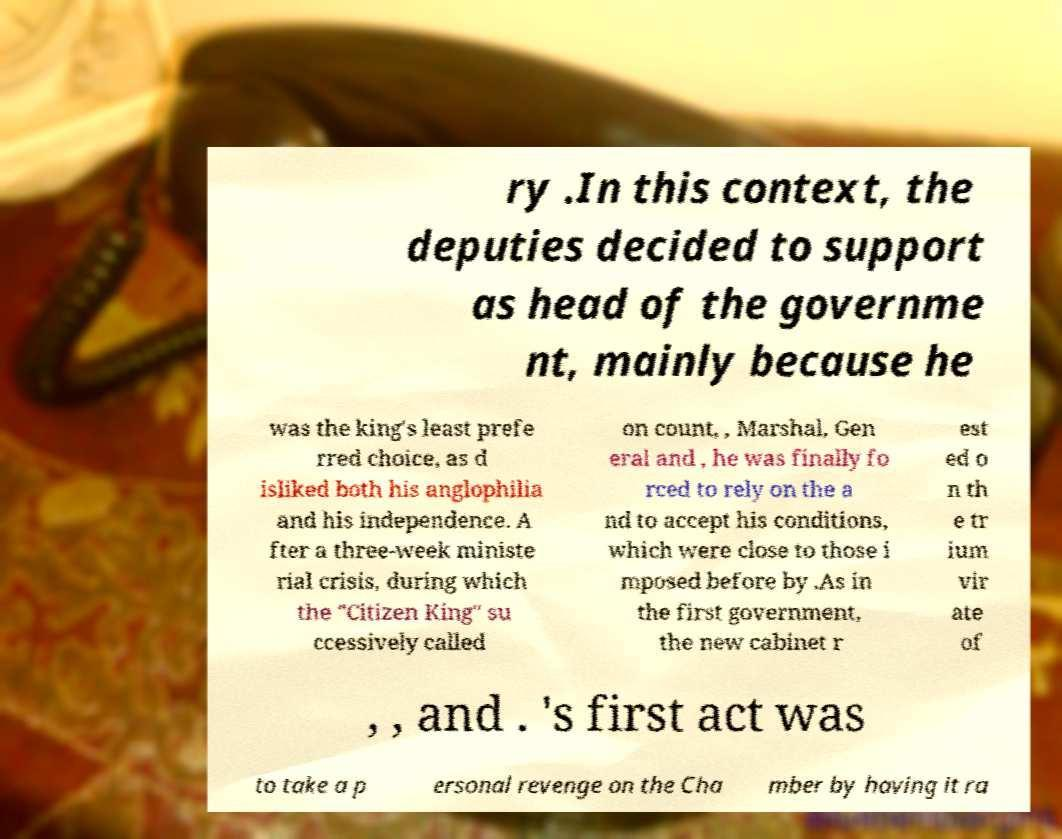Can you accurately transcribe the text from the provided image for me? ry .In this context, the deputies decided to support as head of the governme nt, mainly because he was the king's least prefe rred choice, as d isliked both his anglophilia and his independence. A fter a three-week ministe rial crisis, during which the "Citizen King" su ccessively called on count, , Marshal, Gen eral and , he was finally fo rced to rely on the a nd to accept his conditions, which were close to those i mposed before by .As in the first government, the new cabinet r est ed o n th e tr ium vir ate of , , and . 's first act was to take a p ersonal revenge on the Cha mber by having it ra 